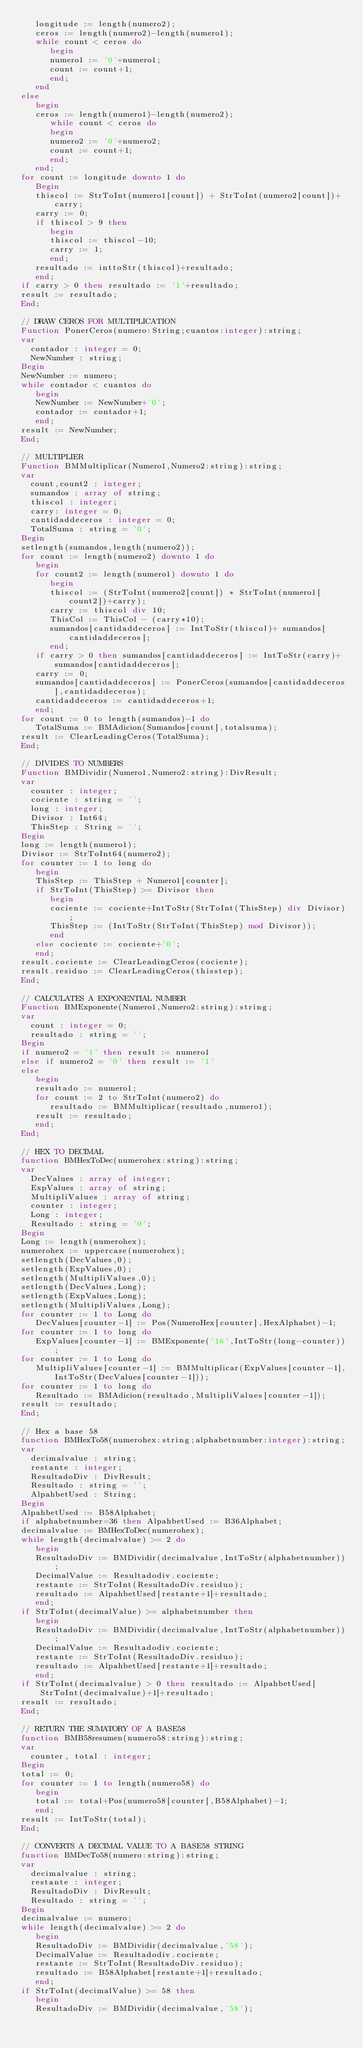Convert code to text. <code><loc_0><loc_0><loc_500><loc_500><_Pascal_>   longitude := length(numero2);
   ceros := length(numero2)-length(numero1);
   while count < ceros do
      begin
      numero1 := '0'+numero1;
      count := count+1;
      end;
   end
else
   begin
   ceros := length(numero1)-length(numero2);
      while count < ceros do
      begin
      numero2 := '0'+numero2;
      count := count+1;
      end;
   end;
for count := longitude downto 1 do
   Begin
   thiscol := StrToInt(numero1[count]) + StrToInt(numero2[count])+carry;
   carry := 0;
   if thiscol > 9 then
      begin
      thiscol := thiscol-10;
      carry := 1;
      end;
   resultado := inttoStr(thiscol)+resultado;
   end;
if carry > 0 then resultado := '1'+resultado;
result := resultado;
End;

// DRAW CEROS FOR MULTIPLICATION
Function PonerCeros(numero:String;cuantos:integer):string;
var
  contador : integer = 0;
  NewNumber : string;
Begin
NewNumber := numero;
while contador < cuantos do
   begin
   NewNumber := NewNumber+'0';
   contador := contador+1;
   end;
result := NewNumber;
End;

// MULTIPLIER
Function BMMultiplicar(Numero1,Numero2:string):string;
var
  count,count2 : integer;
  sumandos : array of string;
  thiscol : integer;
  carry: integer = 0;
  cantidaddeceros : integer = 0;
  TotalSuma : string = '0';
Begin
setlength(sumandos,length(numero2));
for count := length(numero2) downto 1 do
   begin
   for count2 := length(numero1) downto 1 do
      begin
      thiscol := (StrToInt(numero2[count]) * StrToInt(numero1[count2])+carry);
      carry := thiscol div 10;
      ThisCol := ThisCol - (carry*10);
      sumandos[cantidaddeceros] := IntToStr(thiscol)+ sumandos[cantidaddeceros];
      end;
   if carry > 0 then sumandos[cantidaddeceros] := IntToStr(carry)+sumandos[cantidaddeceros];
   carry := 0;
   sumandos[cantidaddeceros] := PonerCeros(sumandos[cantidaddeceros],cantidaddeceros);
   cantidaddeceros := cantidaddeceros+1;
   end;
for count := 0 to length(sumandos)-1 do
   TotalSuma := BMAdicion(Sumandos[count],totalsuma);
result := ClearLeadingCeros(TotalSuma);
End;

// DIVIDES TO NUMBERS
Function BMDividir(Numero1,Numero2:string):DivResult;
var
  counter : integer;
  cociente : string = '';
  long : integer;
  Divisor : Int64;
  ThisStep : String = '';
Begin
long := length(numero1);
Divisor := StrToInt64(numero2);
for counter := 1 to long do
   begin
   ThisStep := ThisStep + Numero1[counter];
   if StrToInt(ThisStep) >= Divisor then
      begin
      cociente := cociente+IntToStr(StrToInt(ThisStep) div Divisor);
      ThisStep := (IntToStr(StrToInt(ThisStep) mod Divisor));
      end
   else cociente := cociente+'0';
   end;
result.cociente := ClearLeadingCeros(cociente);
result.residuo := ClearLeadingCeros(thisstep);
End;

// CALCULATES A EXPONENTIAL NUMBER
Function BMExponente(Numero1,Numero2:string):string;
var
  count : integer = 0;
  resultado : string = '';
Begin
if numero2 = '1' then result := numero1
else if numero2 = '0' then result := '1'
else
   begin
   resultado := numero1;
   for count := 2 to StrToInt(numero2) do
      resultado := BMMultiplicar(resultado,numero1);
   result := resultado;
   end;
End;

// HEX TO DECIMAL
function BMHexToDec(numerohex:string):string;
var
  DecValues : array of integer;
  ExpValues : array of string;
  MultipliValues : array of string;
  counter : integer;
  Long : integer;
  Resultado : string = '0';
Begin
Long := length(numerohex);
numerohex := uppercase(numerohex);
setlength(DecValues,0);
setlength(ExpValues,0);
setlength(MultipliValues,0);
setlength(DecValues,Long);
setlength(ExpValues,Long);
setlength(MultipliValues,Long);
for counter := 1 to Long do
   DecValues[counter-1] := Pos(NumeroHex[counter],HexAlphabet)-1;
for counter := 1 to long do
   ExpValues[counter-1] := BMExponente('16',IntToStr(long-counter));
for counter := 1 to Long do
   MultipliValues[counter-1] := BMMultiplicar(ExpValues[counter-1],IntToStr(DecValues[counter-1]));
for counter := 1 to long do
   Resultado := BMAdicion(resultado,MultipliValues[counter-1]);
result := resultado;
End;

// Hex a base 58
function BMHexTo58(numerohex:string;alphabetnumber:integer):string;
var
  decimalvalue : string;
  restante : integer;
  ResultadoDiv : DivResult;
  Resultado : string = '';
  AlpahbetUsed : String;
Begin
AlpahbetUsed := B58Alphabet;
if alphabetnumber=36 then AlpahbetUsed := B36Alphabet;
decimalvalue := BMHexToDec(numerohex);
while length(decimalvalue) >= 2 do
   begin
   ResultadoDiv := BMDividir(decimalvalue,IntToStr(alphabetnumber));
   DecimalValue := Resultadodiv.cociente;
   restante := StrToInt(ResultadoDiv.residuo);
   resultado := AlpahbetUsed[restante+1]+resultado;
   end;
if StrToInt(decimalValue) >= alphabetnumber then
   begin
   ResultadoDiv := BMDividir(decimalvalue,IntToStr(alphabetnumber));
   DecimalValue := Resultadodiv.cociente;
   restante := StrToInt(ResultadoDiv.residuo);
   resultado := AlpahbetUsed[restante+1]+resultado;
   end;
if StrToInt(decimalvalue) > 0 then resultado := AlpahbetUsed[StrToInt(decimalvalue)+1]+resultado;
result := resultado;
End;

// RETURN THE SUMATORY OF A BASE58
function BMB58resumen(numero58:string):string;
var
  counter, total : integer;
Begin
total := 0;
for counter := 1 to length(numero58) do
   begin
   total := total+Pos(numero58[counter],B58Alphabet)-1;
   end;
result := IntToStr(total);
End;

// CONVERTS A DECIMAL VALUE TO A BASE58 STRING
function BMDecTo58(numero:string):string;
var
  decimalvalue : string;
  restante : integer;
  ResultadoDiv : DivResult;
  Resultado : string = '';
Begin
decimalvalue := numero;
while length(decimalvalue) >= 2 do
   begin
   ResultadoDiv := BMDividir(decimalvalue,'58');
   DecimalValue := Resultadodiv.cociente;
   restante := StrToInt(ResultadoDiv.residuo);
   resultado := B58Alphabet[restante+1]+resultado;
   end;
if StrToInt(decimalValue) >= 58 then
   begin
   ResultadoDiv := BMDividir(decimalvalue,'58');</code> 